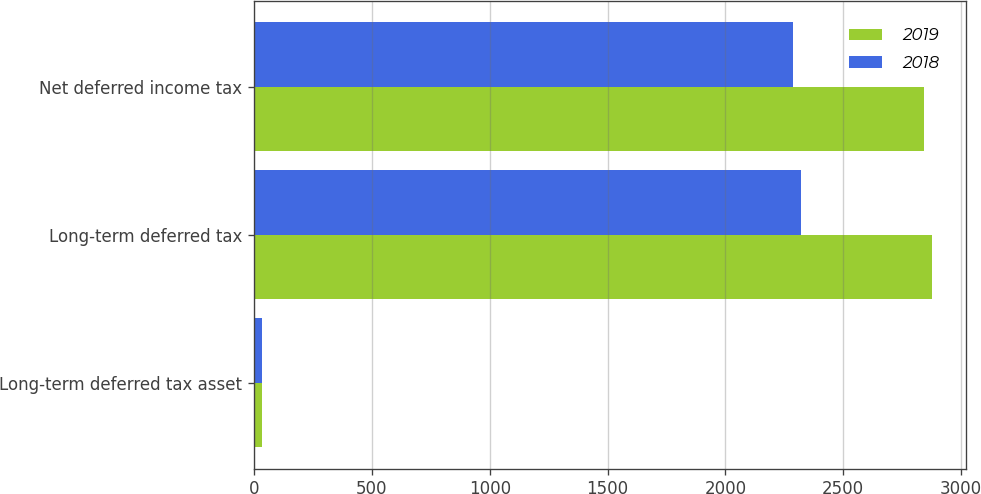Convert chart. <chart><loc_0><loc_0><loc_500><loc_500><stacked_bar_chart><ecel><fcel>Long-term deferred tax asset<fcel>Long-term deferred tax<fcel>Net deferred income tax<nl><fcel>2019<fcel>33.5<fcel>2878<fcel>2844.5<nl><fcel>2018<fcel>35.2<fcel>2321.5<fcel>2286.3<nl></chart> 